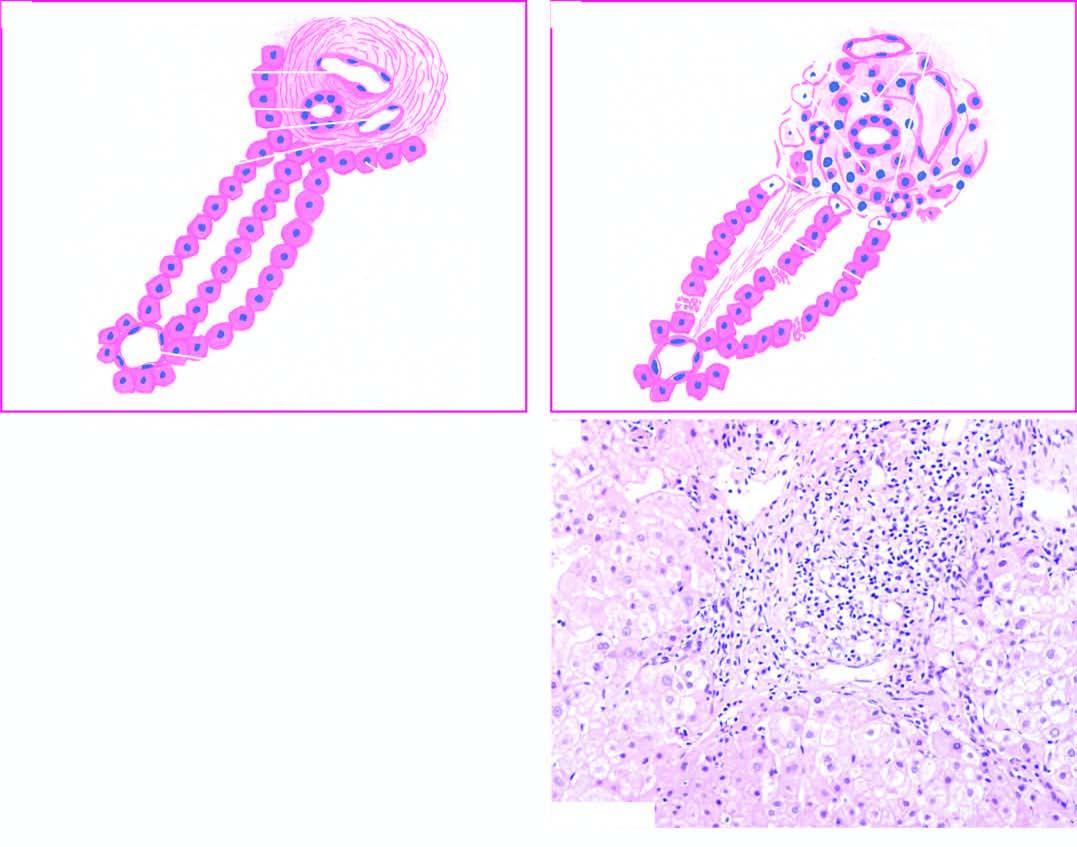does one marrow show stellate-shaped portal triad, with extension of fibrous spurs into lobules?
Answer the question using a single word or phrase. No 